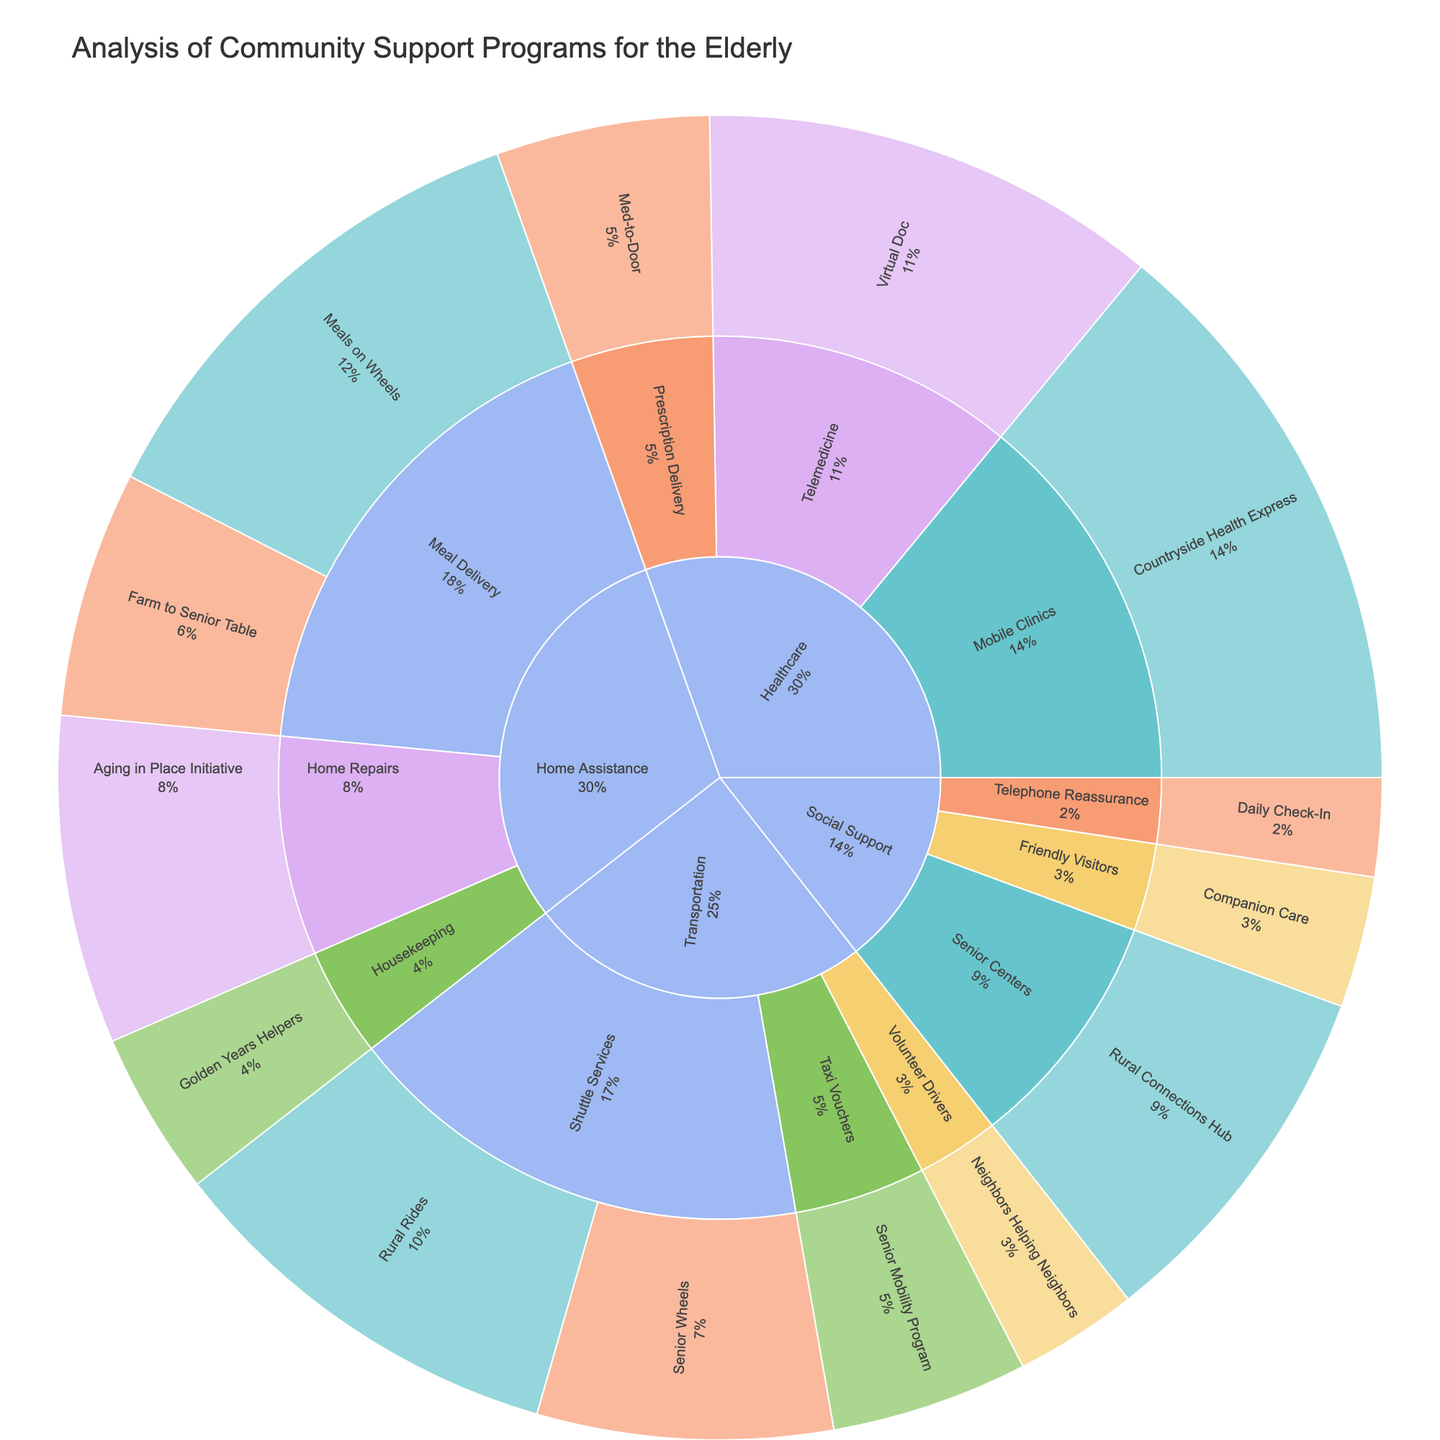What is the total value of transportation assistance programs? Sum the values of all transportation assistance programs: Rural Rides (250,000) + Senior Wheels (180,000) + Neighbors Helping Neighbors (75,000) + Senior Mobility Program (120,000) = 625,000
Answer: 625,000 Which funding source provides the highest value for healthcare programs? Compare the values of healthcare programs by funding sources: Federal Grant (350,000), Private Foundation (280,000), State Funding (130,000).
Answer: Federal Grant Which subcategory within Home Assistance has the highest total value? Sum the values within each subcategory of Home Assistance: Meal Delivery (Meals on Wheels 300,000 + Farm to Senior Table 150,000) = 450,000, Home Repairs (Aging in Place Initiative 200,000), Housekeeping (Golden Years Helpers 100,000).
Answer: Meal Delivery How much funding does the State Funding source contribute to all programs? Sum the values of all programs funded by State Funding: Senior Wheels (180,000) + Farm to Senior Table (150,000) + Daily Check-In (60,000) + Med-to-Door (130,000) = 520,000
Answer: 520,000 Which social support program receives the least funding? Compare the values of social support programs: Companion Care (80,000), Rural Connections Hub (220,000), Daily Check-In (60,000).
Answer: Daily Check-In What is the total value of programs funded by community donations? Sum the values of all programs funded by community donations: Neighbors Helping Neighbors (75,000) + Companion Care (80,000) = 155,000
Answer: 155,000 Which category has the most diverse set of funding sources (i.e., the most different funding sources)? Identify unique funding sources for each category: Transportation (Federal Grant, State Funding, Community Donations, County Budget), Home Assistance (Federal Grant, State Funding, Private Foundation, County Budget), Social Support (Community Donations, Federal Grant, State Funding), Healthcare (Federal Grant, Private Foundation, State Funding).
Answer: Transportation and Home Assistance (tie) Within the Transportation category, which specific program has the highest funding value? Compare the values of all transportation programs: Rural Rides (250,000), Senior Wheels (180,000), Neighbors Helping Neighbors (75,000), Senior Mobility Program (120,000).
Answer: Rural Rides What percentage of the total value is contributed by Federal Grant funded programs in the plot? Sum the values of Federal Grant funded programs and calculate the percentage of the total value: Rural Rides (250,000) + Meals on Wheels (300,000) + Rural Connections Hub (220,000) + Countryside Health Express (350,000) = 1,120,000. Then, find the total value of all programs and divide: (1,120,000 / Sum of all values) * 100.
Answer: ~32% Which category has the highest total funding value? Sum the values of all programs within each category: Transportation (625,000), Home Assistance (750,000), Social Support (360,000), Healthcare (760,000).
Answer: Healthcare 